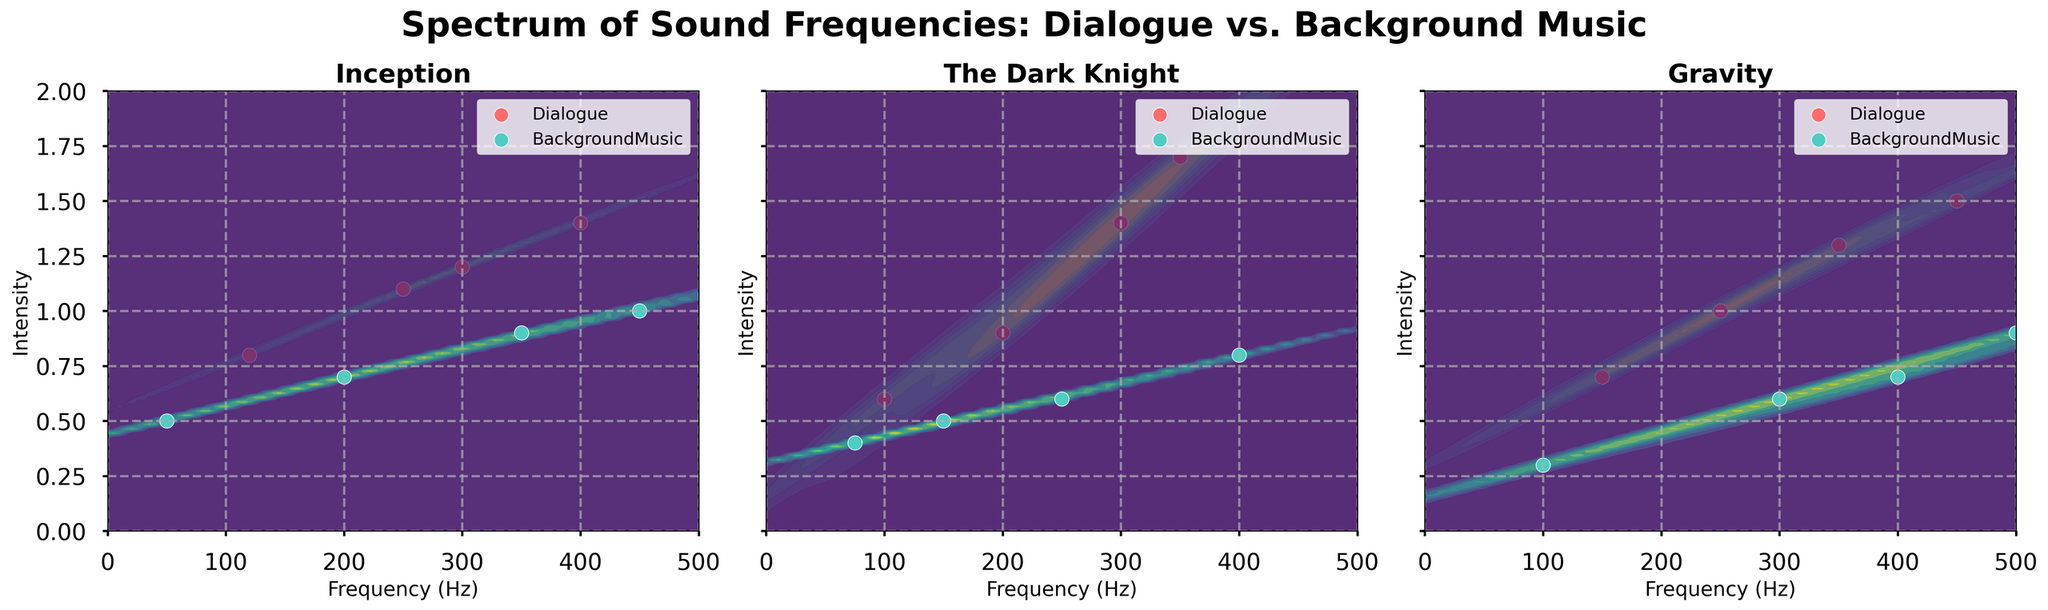What is the title of the figure? The title of the figure is prominently displayed at the top of the plot.
Answer: Spectrum of Sound Frequencies: Dialogue vs. Background Music What are the colors used to represent Dialogue and Background Music? In the figure, Dialogue is represented using a reddish color, and Background Music is represented using a teal color.
Answer: Dialogue is red, and BackgroundMusic is teal Which film has the highest intensity for Dialogue, and what is that intensity? From the figure, the highest point for the Dialogue plot in "The Dark Knight" reaches up to 1.7 in intensity.
Answer: The Dark Knight, intensity 1.7 In "Gravity," what is the frequency range where Background Music has the highest density? Inspecting the contour density plot for "Gravity," Background Music shows the highest density around the frequency of 400 Hz.
Answer: Around 400 Hz How do the frequency distributions of Dialogue and Background Music compare in "Inception"? By looking at the density plots in the "Inception" subplot, both Dialogue and Background Music frequencies are spread out, but Dialogue shows greater density in the frequency range of 200-400 Hz, whereas Background Music is more spread across lower frequencies.
Answer: Dialogue: 200-400 Hz, Background Music: lower frequencies What is the range of intensities for Background Music in "The Dark Knight"? The intensities for Background Music in "The Dark Knight" subplot seem to range from 0.4 to 0.8.
Answer: 0.4 to 0.8 Between "Inception" and "Gravity," which film has a higher intensity for Dialogue at the same frequency? Specify the frequency and intensity. Comparing the density plots for both films, at 350 Hz, "Gravity" has a higher intensity of 1.3 compared to "Inception" with an intensity of 1.2.
Answer: Gravity at 350 Hz: 1.3, Inception at 350 Hz: 1.2 What is the common frequency range that both Dialogue and Background Music share across all films? The common frequency range, as seen in the combined subplots, stretches between approximately 150-400 Hz for both Dialogue and Background Music.
Answer: 150-400 Hz 